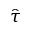Convert formula to latex. <formula><loc_0><loc_0><loc_500><loc_500>\hat { \tau }</formula> 